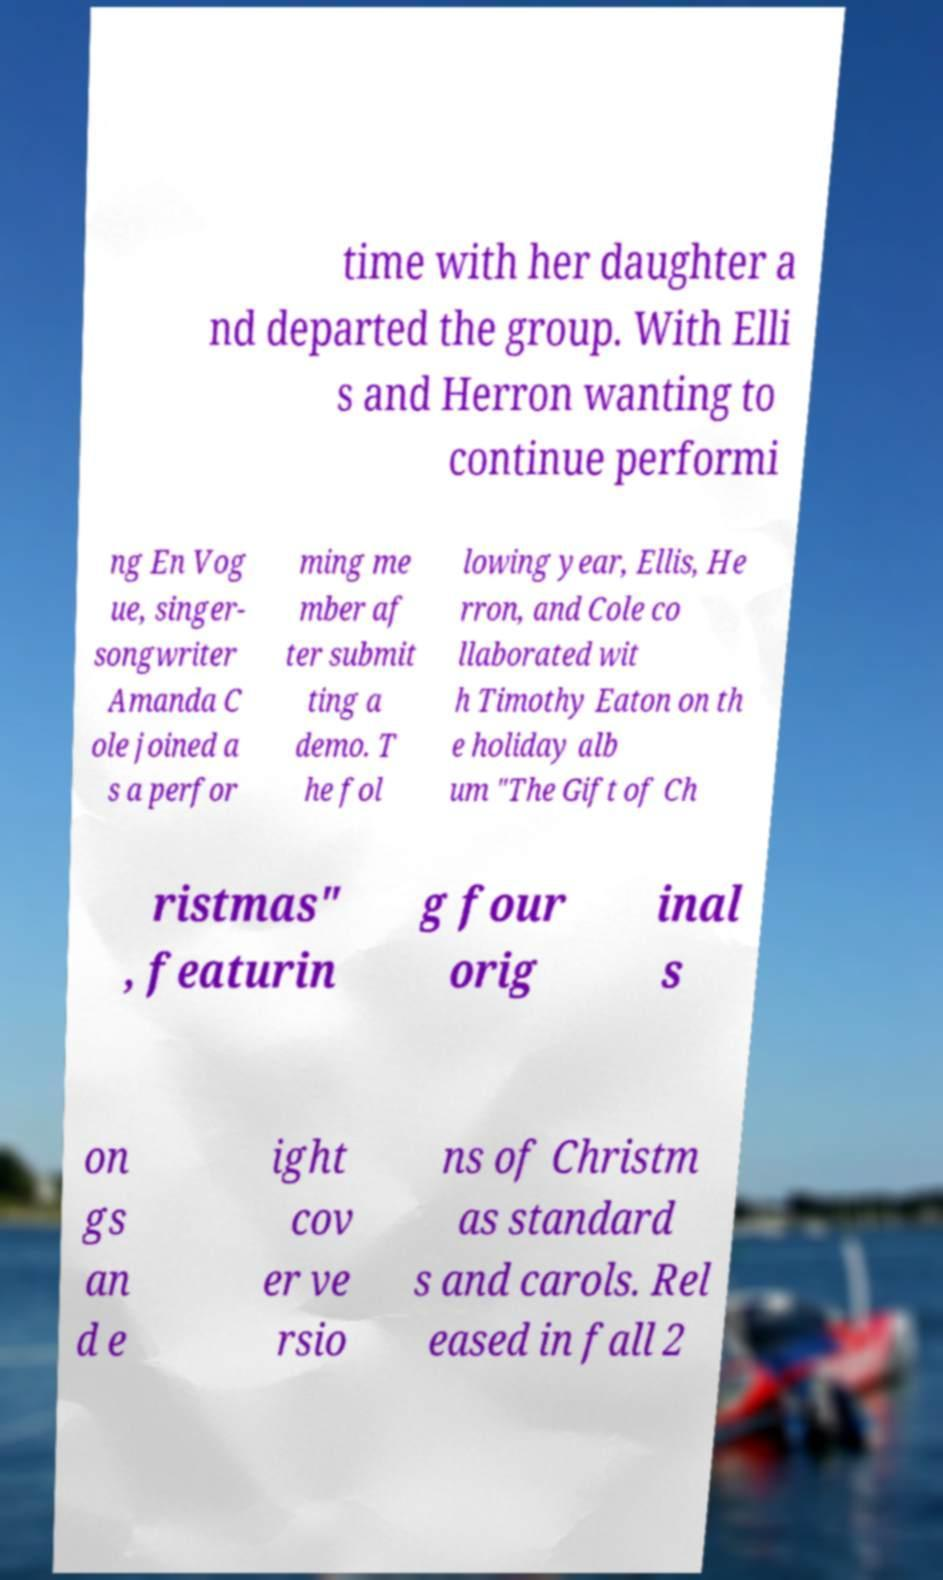I need the written content from this picture converted into text. Can you do that? time with her daughter a nd departed the group. With Elli s and Herron wanting to continue performi ng En Vog ue, singer- songwriter Amanda C ole joined a s a perfor ming me mber af ter submit ting a demo. T he fol lowing year, Ellis, He rron, and Cole co llaborated wit h Timothy Eaton on th e holiday alb um "The Gift of Ch ristmas" , featurin g four orig inal s on gs an d e ight cov er ve rsio ns of Christm as standard s and carols. Rel eased in fall 2 